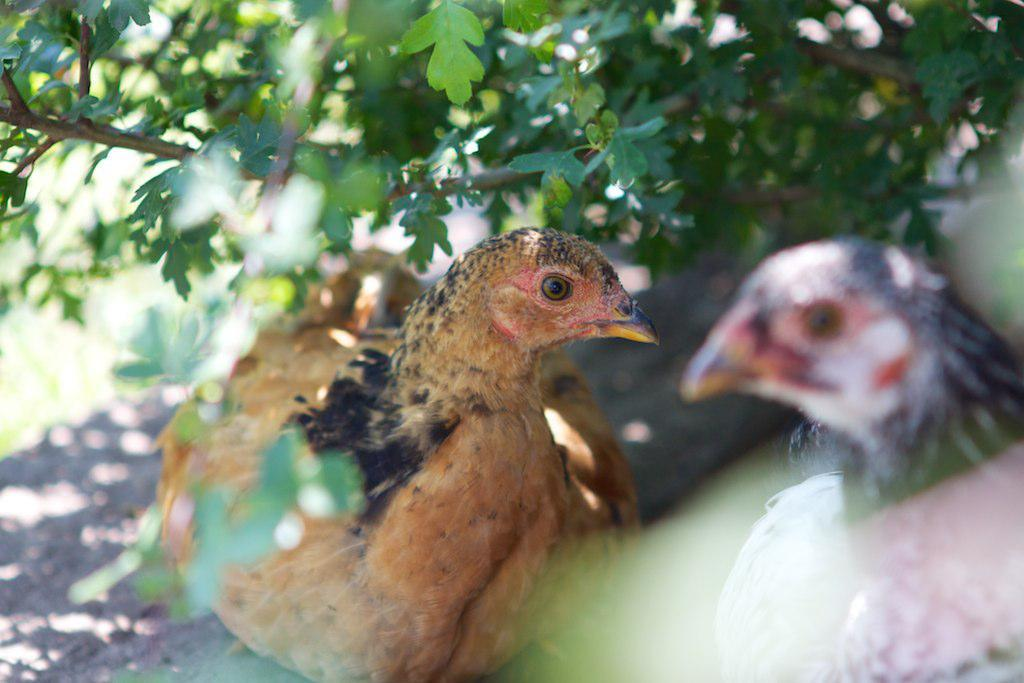What animals are present in the image? There are two hens in the image. What type of vegetation can be seen in the image? Trees are visible at the top of the image. How would you describe the background of the image? The background of the image is blurred. What color is the scarf that the hens are wearing in the image? There are no scarves present in the image, as the hens are not wearing any clothing. 